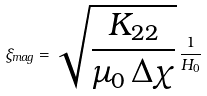Convert formula to latex. <formula><loc_0><loc_0><loc_500><loc_500>\xi _ { m a g } = \sqrt { \frac { K _ { 2 2 } } { \mu _ { 0 } \, \Delta \chi } } \, \frac { 1 } { H _ { 0 } }</formula> 